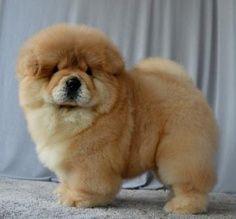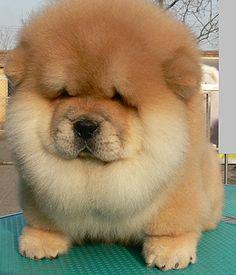The first image is the image on the left, the second image is the image on the right. Assess this claim about the two images: "Only one dog is not in the grass.". Correct or not? Answer yes or no. No. The first image is the image on the left, the second image is the image on the right. Assess this claim about the two images: "One dog has his left front paw off the ground.". Correct or not? Answer yes or no. No. 